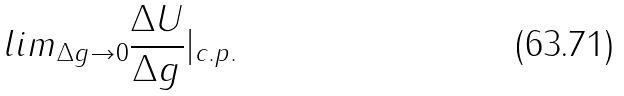Convert formula to latex. <formula><loc_0><loc_0><loc_500><loc_500>l i m _ { \Delta g \rightarrow 0 } \frac { \Delta U } { \Delta g } | _ { c . p . }</formula> 